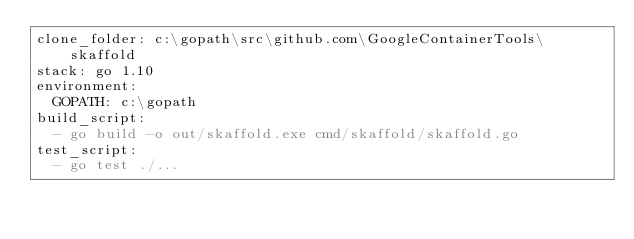Convert code to text. <code><loc_0><loc_0><loc_500><loc_500><_YAML_>clone_folder: c:\gopath\src\github.com\GoogleContainerTools\skaffold
stack: go 1.10
environment:
  GOPATH: c:\gopath
build_script:
  - go build -o out/skaffold.exe cmd/skaffold/skaffold.go
test_script:
  - go test ./...</code> 